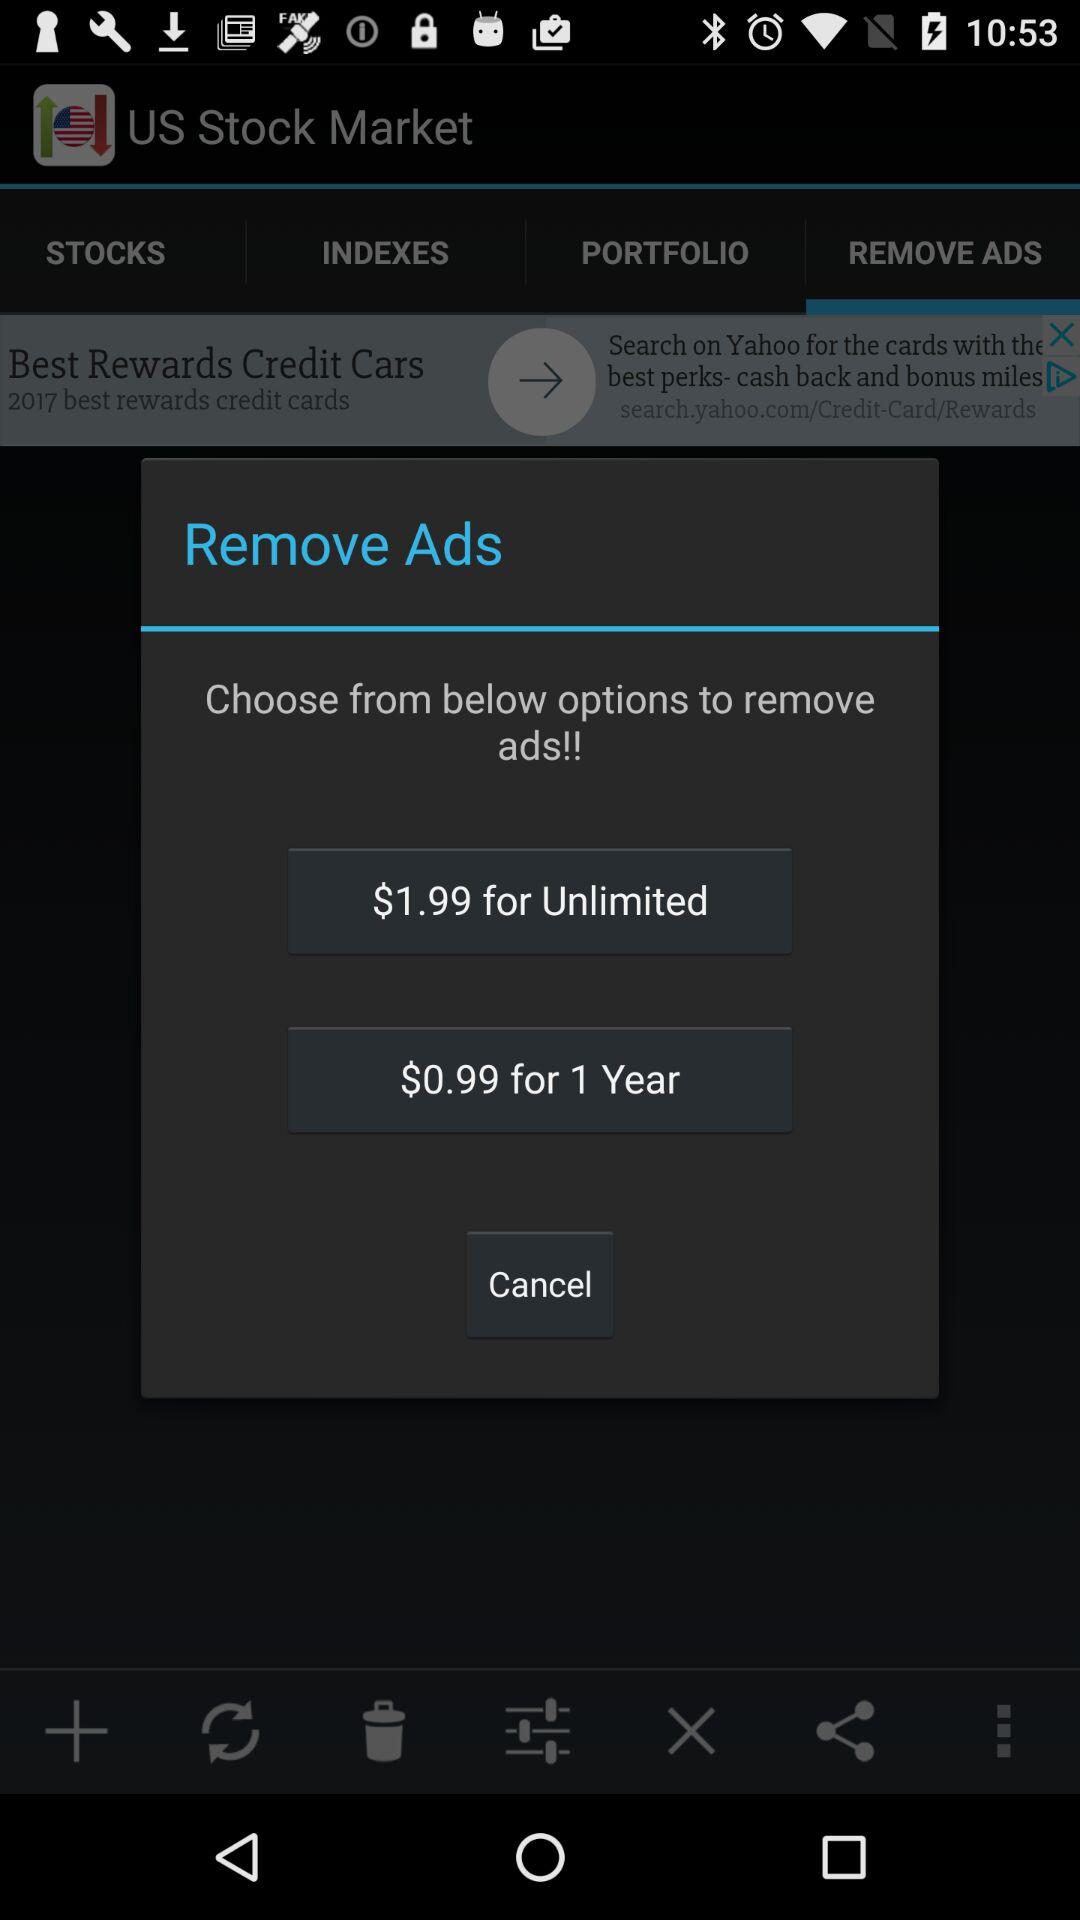What is the price for a year? The price for a year is $0.99. 